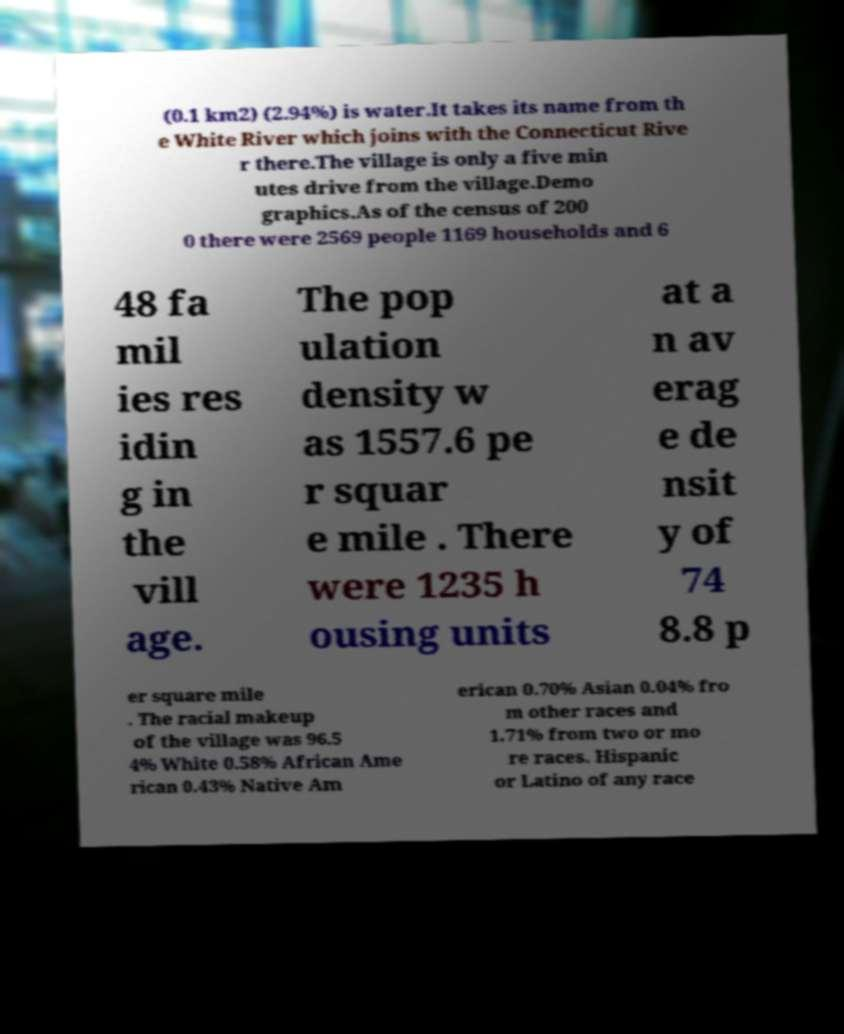Please read and relay the text visible in this image. What does it say? (0.1 km2) (2.94%) is water.It takes its name from th e White River which joins with the Connecticut Rive r there.The village is only a five min utes drive from the village.Demo graphics.As of the census of 200 0 there were 2569 people 1169 households and 6 48 fa mil ies res idin g in the vill age. The pop ulation density w as 1557.6 pe r squar e mile . There were 1235 h ousing units at a n av erag e de nsit y of 74 8.8 p er square mile . The racial makeup of the village was 96.5 4% White 0.58% African Ame rican 0.43% Native Am erican 0.70% Asian 0.04% fro m other races and 1.71% from two or mo re races. Hispanic or Latino of any race 